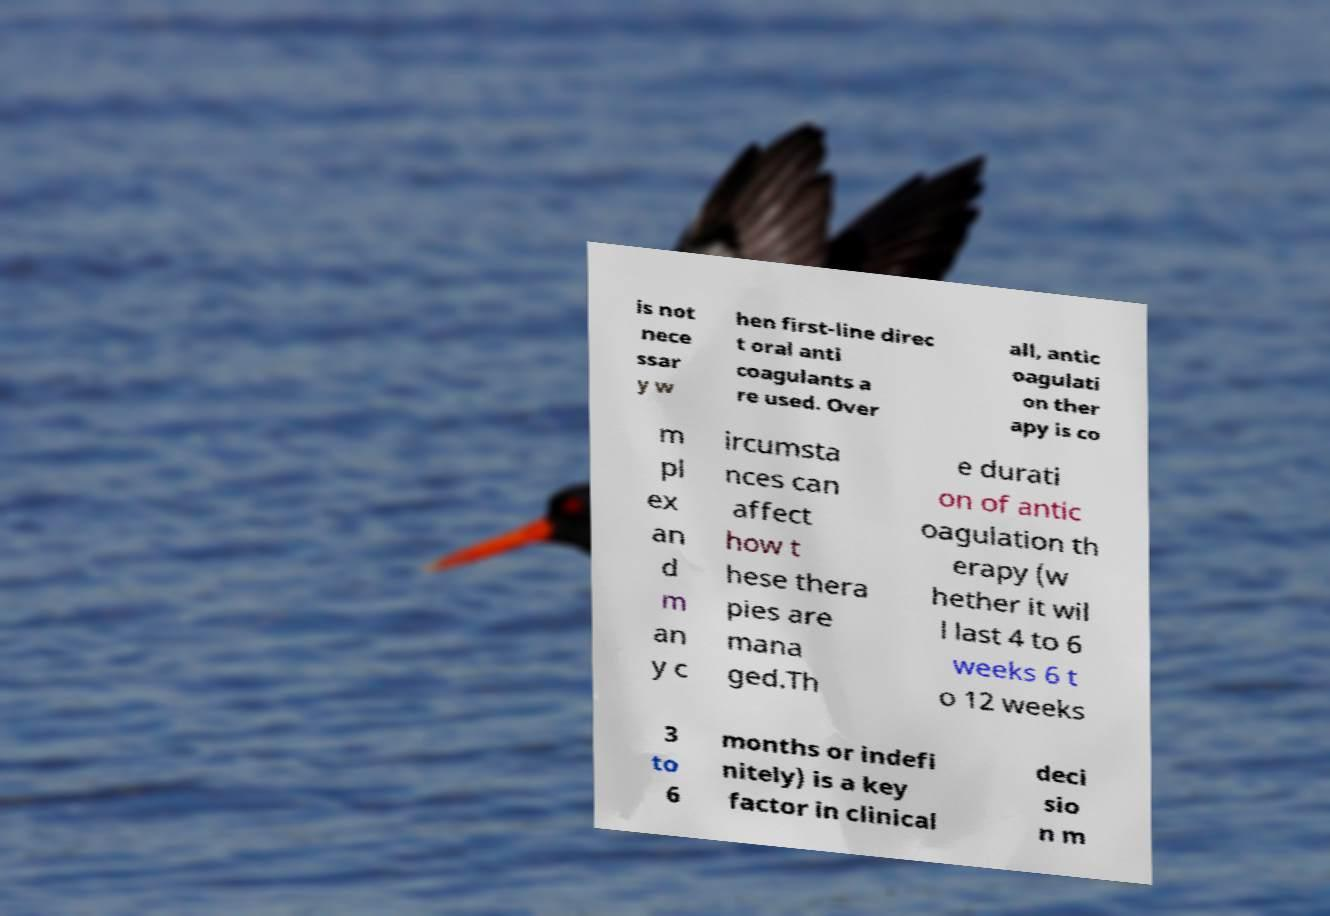Please identify and transcribe the text found in this image. is not nece ssar y w hen first-line direc t oral anti coagulants a re used. Over all, antic oagulati on ther apy is co m pl ex an d m an y c ircumsta nces can affect how t hese thera pies are mana ged.Th e durati on of antic oagulation th erapy (w hether it wil l last 4 to 6 weeks 6 t o 12 weeks 3 to 6 months or indefi nitely) is a key factor in clinical deci sio n m 